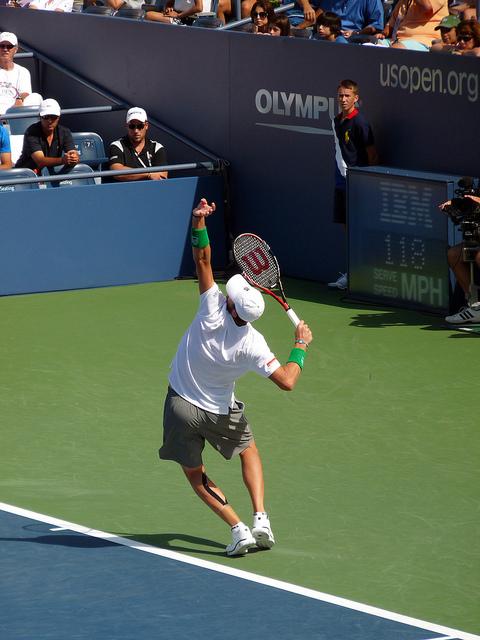What letter is on the racket?
Write a very short answer. W. What does the "MPH" on the sign stand for?
Give a very brief answer. Miles per hour. What color is the man's shirt?
Quick response, please. White. 